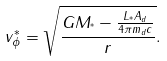<formula> <loc_0><loc_0><loc_500><loc_500>v ^ { * } _ { \phi } = \sqrt { \frac { G M _ { ^ { * } } - \frac { L _ { ^ { * } } A _ { d } } { 4 \pi m _ { d } c } } { r } } .</formula> 